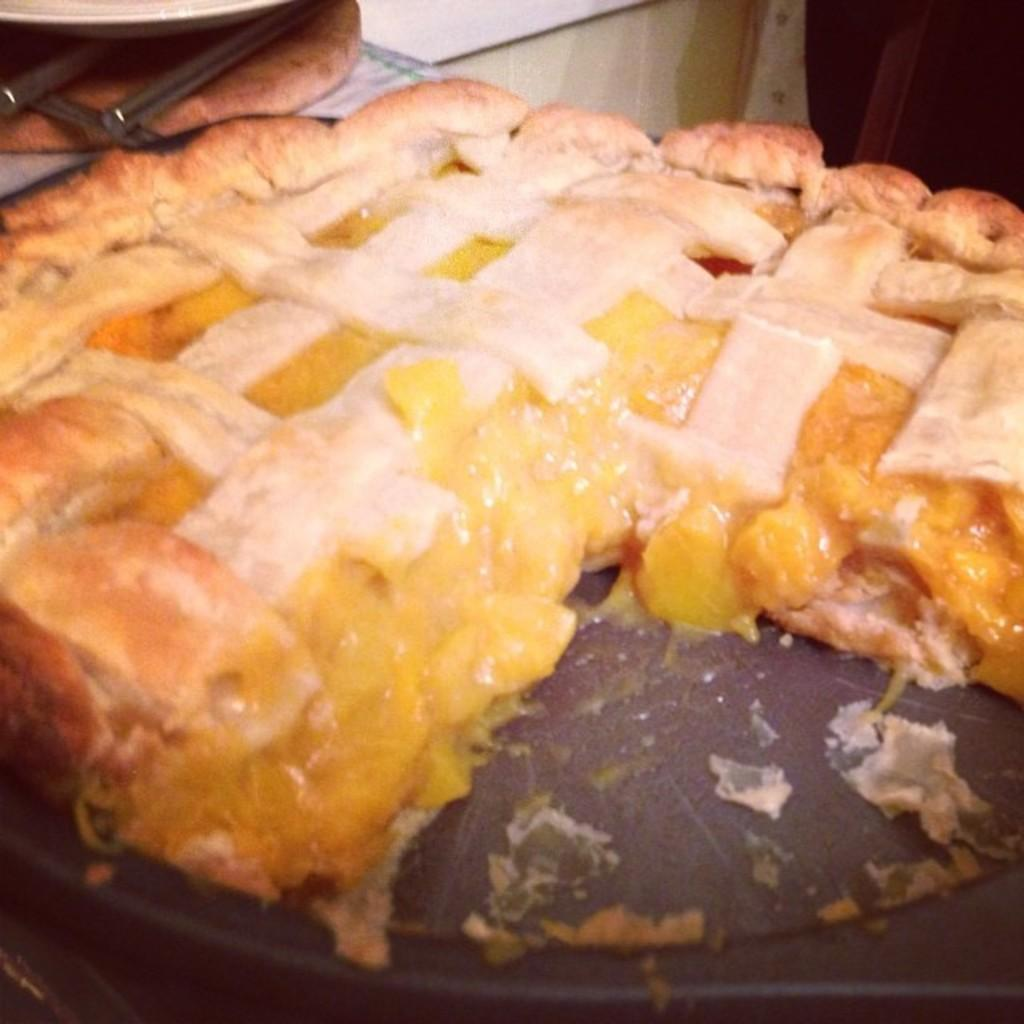What is the main subject of the image? There is a food item on a plate in the image. What type of earth is visible in the image? There is no earth visible in the image; it features a food item on a plate. What town is depicted in the image? There is no town present in the image; it features a food item on a plate. 